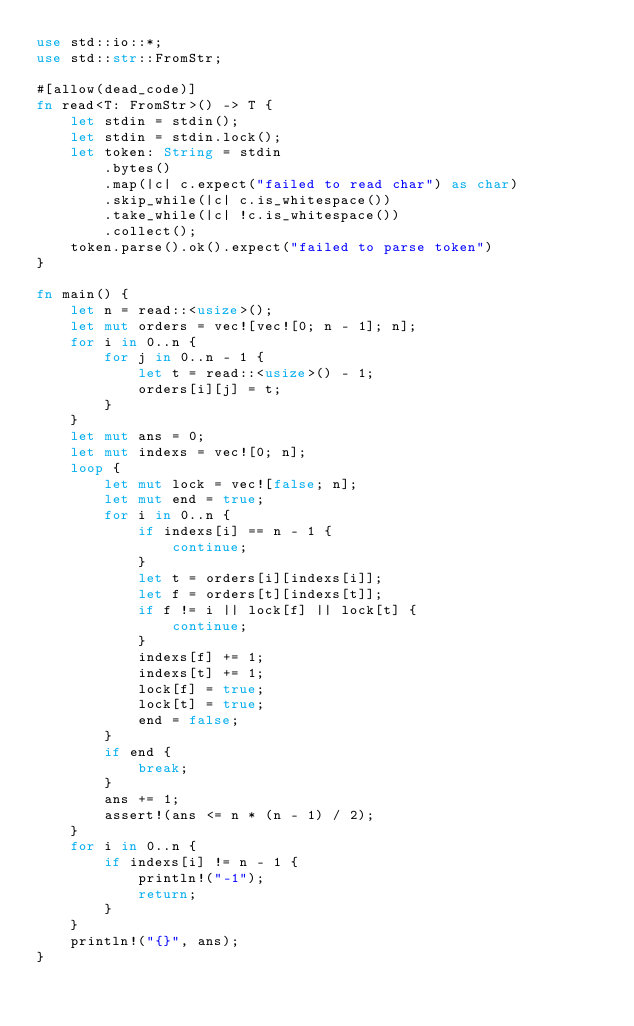Convert code to text. <code><loc_0><loc_0><loc_500><loc_500><_Rust_>use std::io::*;
use std::str::FromStr;

#[allow(dead_code)]
fn read<T: FromStr>() -> T {
    let stdin = stdin();
    let stdin = stdin.lock();
    let token: String = stdin
        .bytes()
        .map(|c| c.expect("failed to read char") as char)
        .skip_while(|c| c.is_whitespace())
        .take_while(|c| !c.is_whitespace())
        .collect();
    token.parse().ok().expect("failed to parse token")
}

fn main() {
    let n = read::<usize>();
    let mut orders = vec![vec![0; n - 1]; n];
    for i in 0..n {
        for j in 0..n - 1 {
            let t = read::<usize>() - 1;
            orders[i][j] = t;
        }
    }
    let mut ans = 0;
    let mut indexs = vec![0; n];
    loop {
        let mut lock = vec![false; n];
        let mut end = true;
        for i in 0..n {
            if indexs[i] == n - 1 {
                continue;
            }
            let t = orders[i][indexs[i]];
            let f = orders[t][indexs[t]];
            if f != i || lock[f] || lock[t] {
                continue;
            }
            indexs[f] += 1;
            indexs[t] += 1;
            lock[f] = true;
            lock[t] = true;
            end = false;
        }
        if end {
            break;
        }
        ans += 1;
        assert!(ans <= n * (n - 1) / 2);
    }
    for i in 0..n {
        if indexs[i] != n - 1 {
            println!("-1");
            return;
        }
    }
    println!("{}", ans);
}
</code> 